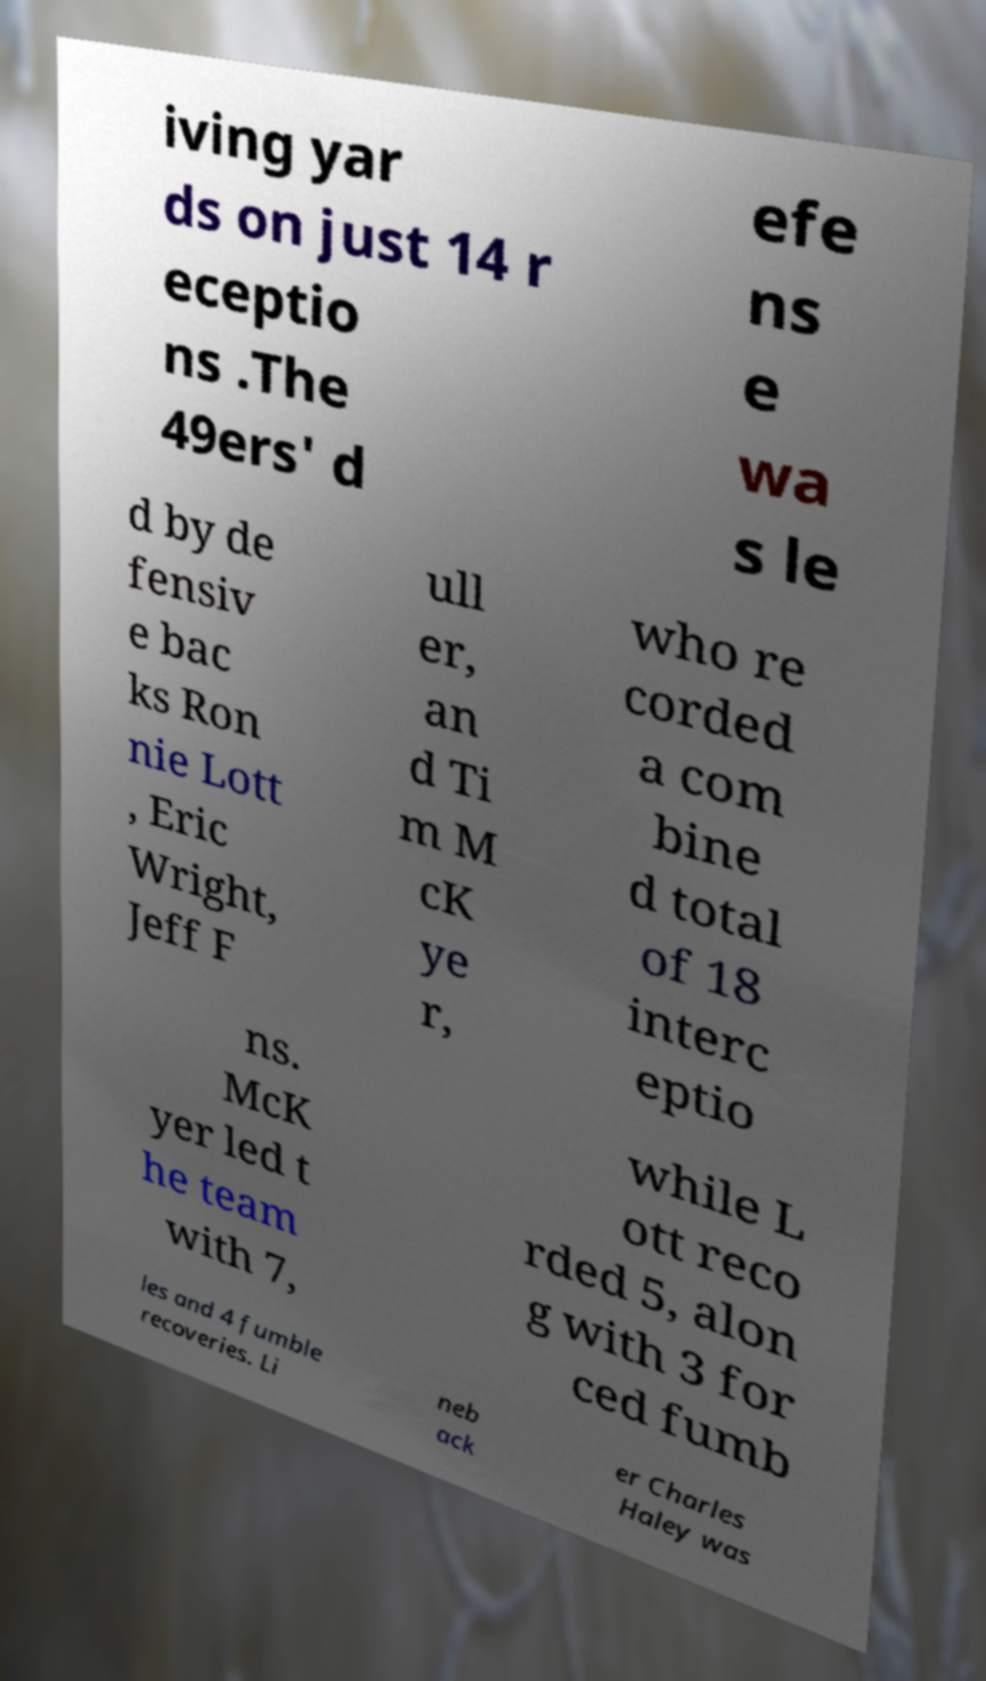I need the written content from this picture converted into text. Can you do that? iving yar ds on just 14 r eceptio ns .The 49ers' d efe ns e wa s le d by de fensiv e bac ks Ron nie Lott , Eric Wright, Jeff F ull er, an d Ti m M cK ye r, who re corded a com bine d total of 18 interc eptio ns. McK yer led t he team with 7, while L ott reco rded 5, alon g with 3 for ced fumb les and 4 fumble recoveries. Li neb ack er Charles Haley was 